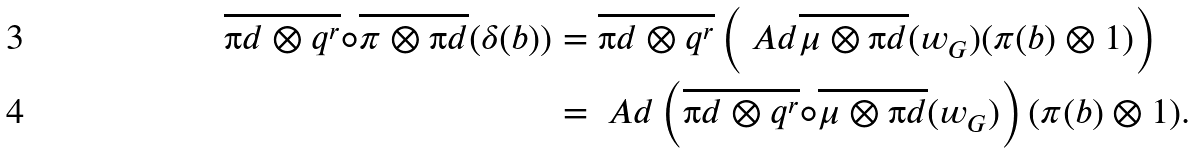Convert formula to latex. <formula><loc_0><loc_0><loc_500><loc_500>\overline { { \i d } \otimes q ^ { r } } \circ \overline { \pi \otimes { \i d } } ( \delta ( b ) ) & = \overline { { \i d } \otimes q ^ { r } } \left ( \ A d \overline { \mu \otimes { \i d } } ( w _ { G } ) ( \pi ( b ) \otimes 1 ) \right ) \\ & = \ A d \left ( \overline { { \i d } \otimes q ^ { r } } \circ \overline { \mu \otimes { \i d } } ( w _ { G } ) \right ) ( \pi ( b ) \otimes 1 ) .</formula> 